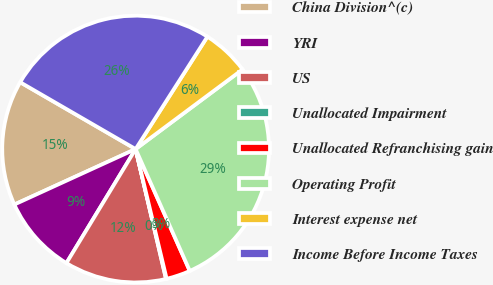Convert chart. <chart><loc_0><loc_0><loc_500><loc_500><pie_chart><fcel>China Division^(c)<fcel>YRI<fcel>US<fcel>Unallocated Impairment<fcel>Unallocated Refranchising gain<fcel>Operating Profit<fcel>Interest expense net<fcel>Income Before Income Taxes<nl><fcel>15.18%<fcel>9.49%<fcel>12.34%<fcel>0.08%<fcel>2.92%<fcel>28.53%<fcel>5.77%<fcel>25.69%<nl></chart> 